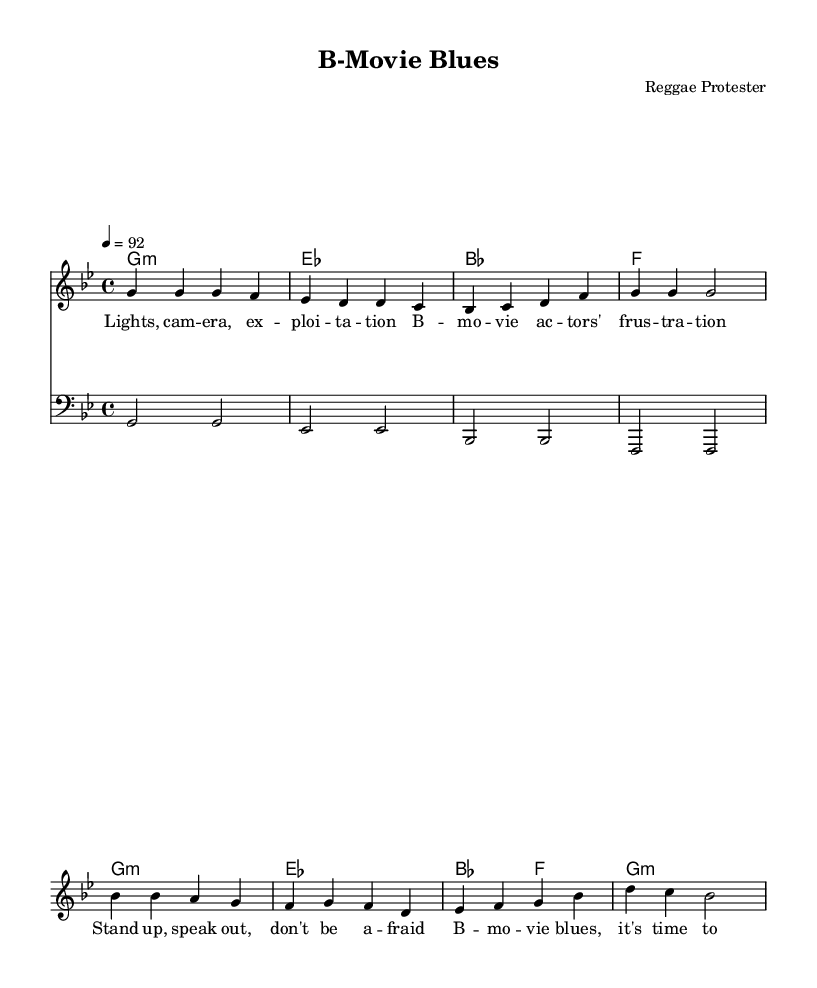What is the key signature of this music? The key signature is G minor, which has two flats (B flat and E flat). This is indicated at the beginning of the staff.
Answer: G minor What is the time signature of this music? The time signature is 4/4, which means there are four beats in each measure and the quarter note gets one beat. This is shown at the beginning of the score.
Answer: 4/4 What is the tempo marking of the piece? The tempo marking indicates a speed of 92 beats per minute, which is noted as "4 = 92". This indicates how fast the music should be played.
Answer: 92 How many measures are in the verse section? The verse section has four measures, as indicated by the group of notes and corresponding rhythms that repeat a specific lyrical content.
Answer: 4 In which section do the lyrics "Stand up, speak out, don't be afraid" appear? These lyrics are found in the chorus section, as they follow the chord progression and melodic line identified as the chorus in the sheet music.
Answer: chorus What is the function of the bass line in this piece? The bass line serves as the harmonic foundation and provides depth to the arrangement, usually outlining the root notes of the chords present in the progression. The bass plays associated notes that complement the melody.
Answer: harmonic foundation What type of song is this classified as based on its lyrical theme? This song is classified as a protest song, particularly due to its critique of the exploitation of actors in B-movies, reflecting social and economic injustices within the entertainment industry.
Answer: protest song 